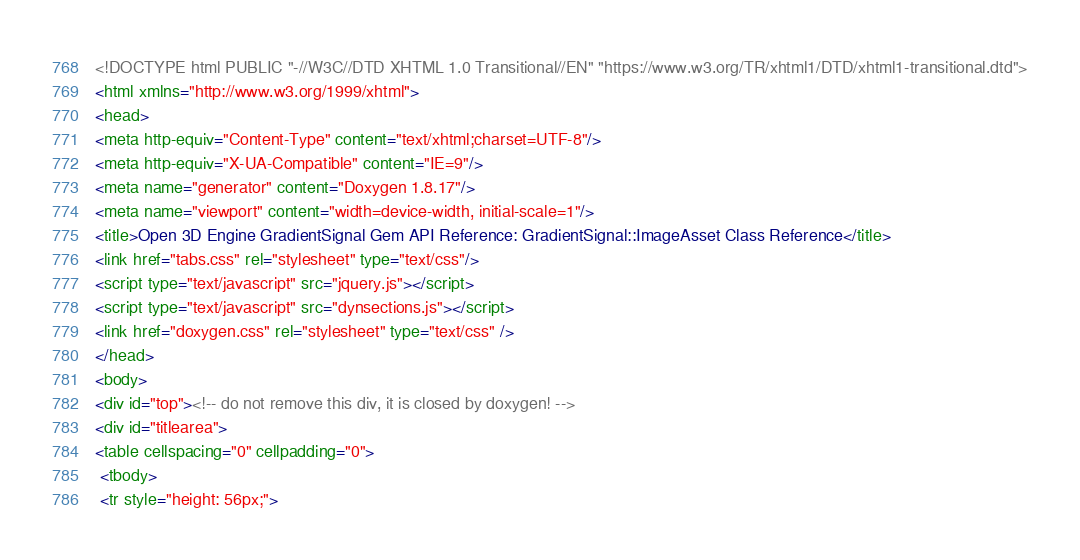Convert code to text. <code><loc_0><loc_0><loc_500><loc_500><_HTML_><!DOCTYPE html PUBLIC "-//W3C//DTD XHTML 1.0 Transitional//EN" "https://www.w3.org/TR/xhtml1/DTD/xhtml1-transitional.dtd">
<html xmlns="http://www.w3.org/1999/xhtml">
<head>
<meta http-equiv="Content-Type" content="text/xhtml;charset=UTF-8"/>
<meta http-equiv="X-UA-Compatible" content="IE=9"/>
<meta name="generator" content="Doxygen 1.8.17"/>
<meta name="viewport" content="width=device-width, initial-scale=1"/>
<title>Open 3D Engine GradientSignal Gem API Reference: GradientSignal::ImageAsset Class Reference</title>
<link href="tabs.css" rel="stylesheet" type="text/css"/>
<script type="text/javascript" src="jquery.js"></script>
<script type="text/javascript" src="dynsections.js"></script>
<link href="doxygen.css" rel="stylesheet" type="text/css" />
</head>
<body>
<div id="top"><!-- do not remove this div, it is closed by doxygen! -->
<div id="titlearea">
<table cellspacing="0" cellpadding="0">
 <tbody>
 <tr style="height: 56px;"></code> 